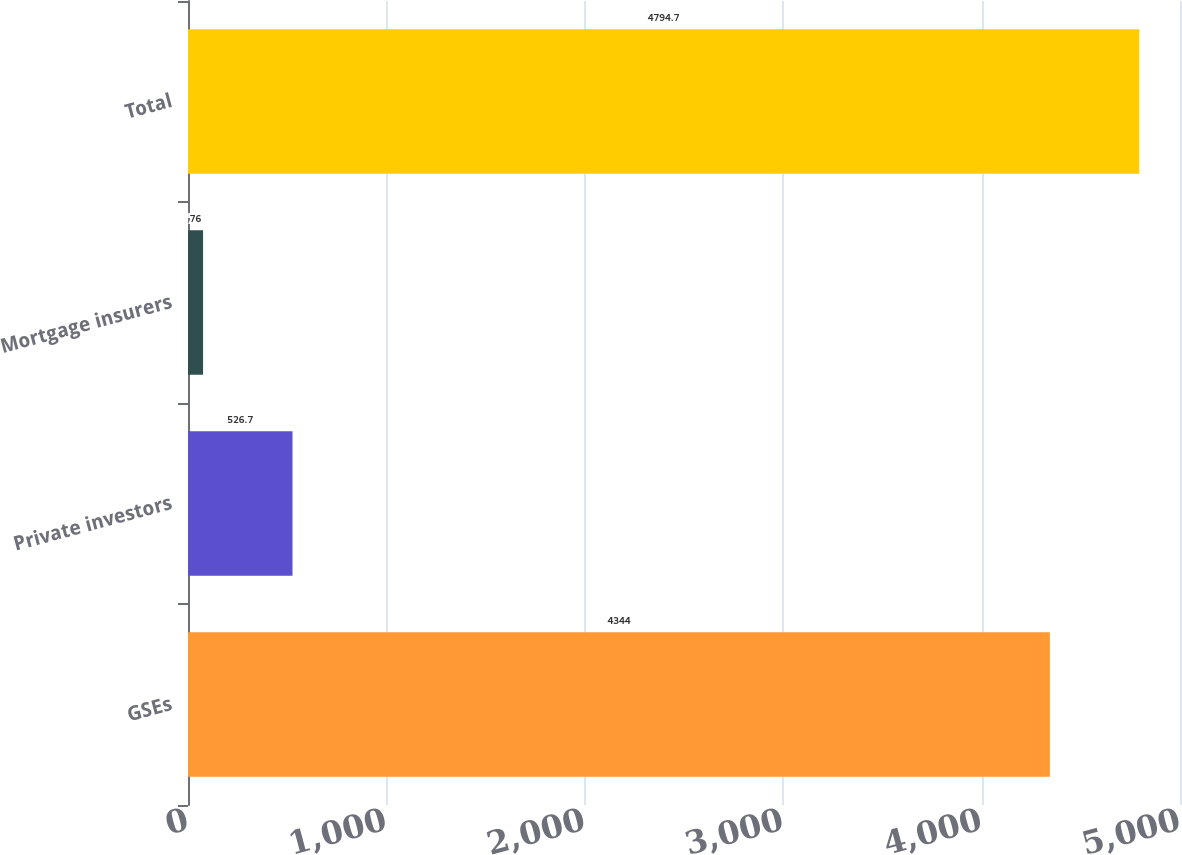Convert chart to OTSL. <chart><loc_0><loc_0><loc_500><loc_500><bar_chart><fcel>GSEs<fcel>Private investors<fcel>Mortgage insurers<fcel>Total<nl><fcel>4344<fcel>526.7<fcel>76<fcel>4794.7<nl></chart> 